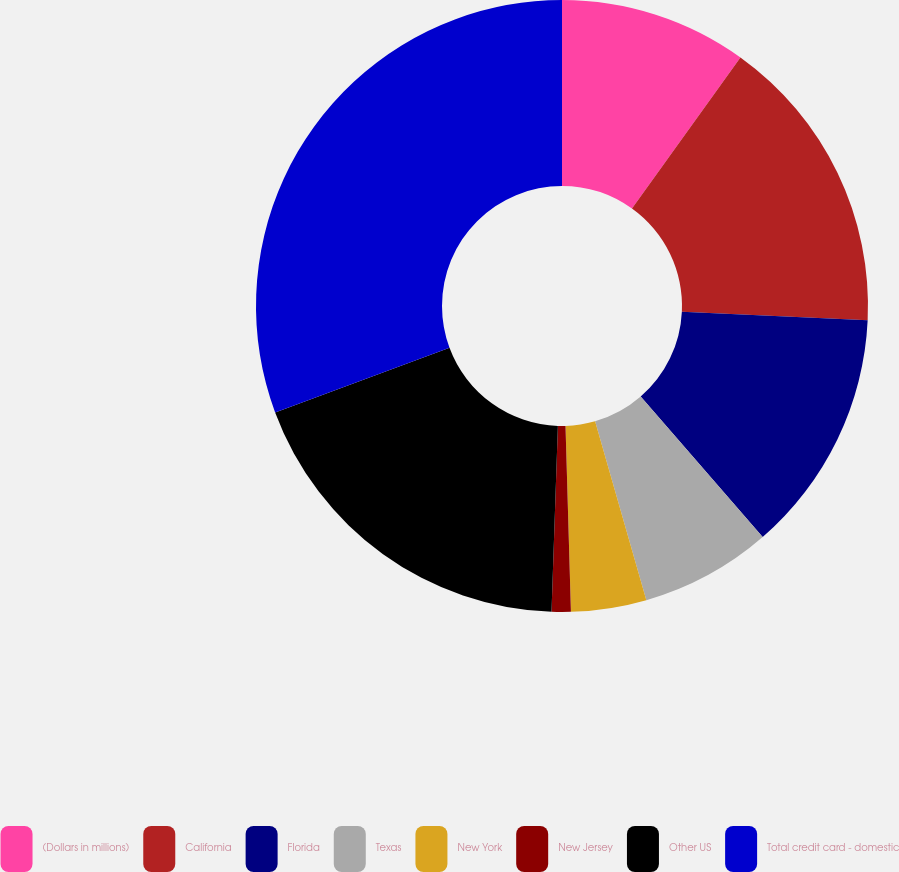<chart> <loc_0><loc_0><loc_500><loc_500><pie_chart><fcel>(Dollars in millions)<fcel>California<fcel>Florida<fcel>Texas<fcel>New York<fcel>New Jersey<fcel>Other US<fcel>Total credit card - domestic<nl><fcel>9.91%<fcel>15.84%<fcel>12.87%<fcel>6.94%<fcel>3.98%<fcel>1.01%<fcel>18.8%<fcel>30.66%<nl></chart> 